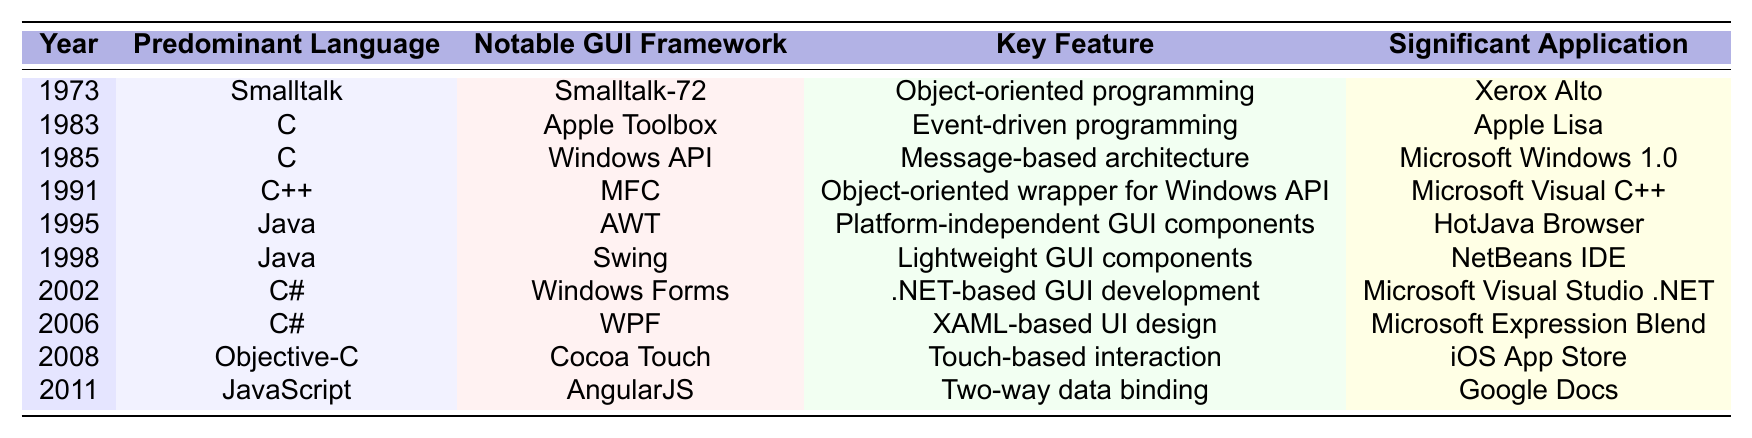What programming language was predominant in 1973? According to the table, the predominant language in 1973 is Smalltalk.
Answer: Smalltalk Which notable GUI framework was associated with the year 1995? The notable GUI framework listed for 1995 is AWT (Abstract Window Toolkit) as per the table.
Answer: AWT What key feature distinguishes C# programming from Java in GUI development? The table shows that C# is associated with .NET-based GUI development, while Java is noted for platform-independent GUI components.
Answer: .NET-based GUI development In which year was the programming language C++ predominantly used for GUI development? The table indicates that C++ was predominantly used in 1991 for GUI development.
Answer: 1991 Was Objective-C the predominant language used in 2008 for GUI development? Yes, according to the table, Objective-C was the predominant language in 2008.
Answer: Yes Which significant applications were developed using Java, and in which years? The table shows that significant applications using Java were HotJava Browser in 1995 and NetBeans IDE in 1998.
Answer: HotJava Browser (1995), NetBeans IDE (1998) What is the predominant language for the notable GUI framework WPF? The predominant language for WPF is C# as indicated in the table.
Answer: C# How many programming languages are listed in the table? The table lists a total of six distinct programming languages used across different years for GUI development: Smalltalk, C, C++, Java, C#, and JavaScript.
Answer: Six What is the significance of the year 1985 in the context of GUI development? In 1985, the predominant programming language was C, associated with the Windows API framework and the key feature was a message-based architecture, significant for the Microsoft Windows 1.0 application.
Answer: Microsoft Windows 1.0 Can you identify a trend in the predominant languages used for GUI development over the years? The table exhibits a trend where the programming languages evolved from Smalltalk in the early years, through C and C++, into modern languages like Java, C#, and JavaScript in later years, indicating a shift towards more versatile and platform-independent languages.
Answer: Shift towards modern languages 